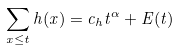<formula> <loc_0><loc_0><loc_500><loc_500>\sum _ { x \leq t } h ( x ) = c _ { h } t ^ { \alpha } + E ( t )</formula> 